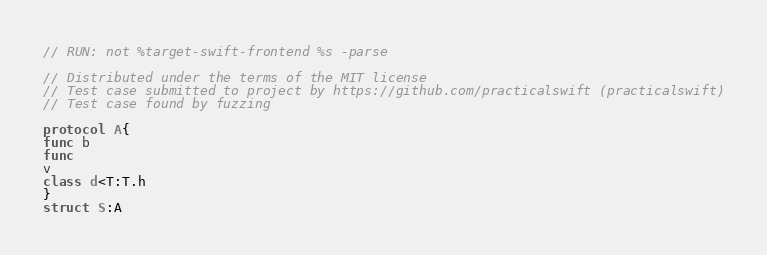<code> <loc_0><loc_0><loc_500><loc_500><_Swift_>// RUN: not %target-swift-frontend %s -parse

// Distributed under the terms of the MIT license
// Test case submitted to project by https://github.com/practicalswift (practicalswift)
// Test case found by fuzzing

protocol A{
func b
func
v
class d<T:T.h
}
struct S:A
</code> 